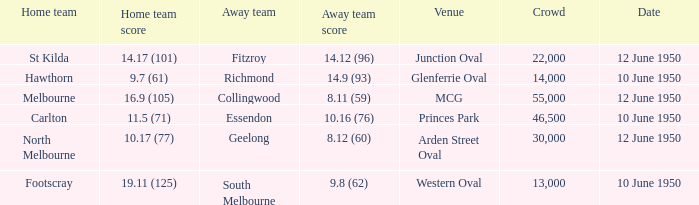What was the crowd when the VFL played MCG? 55000.0. 